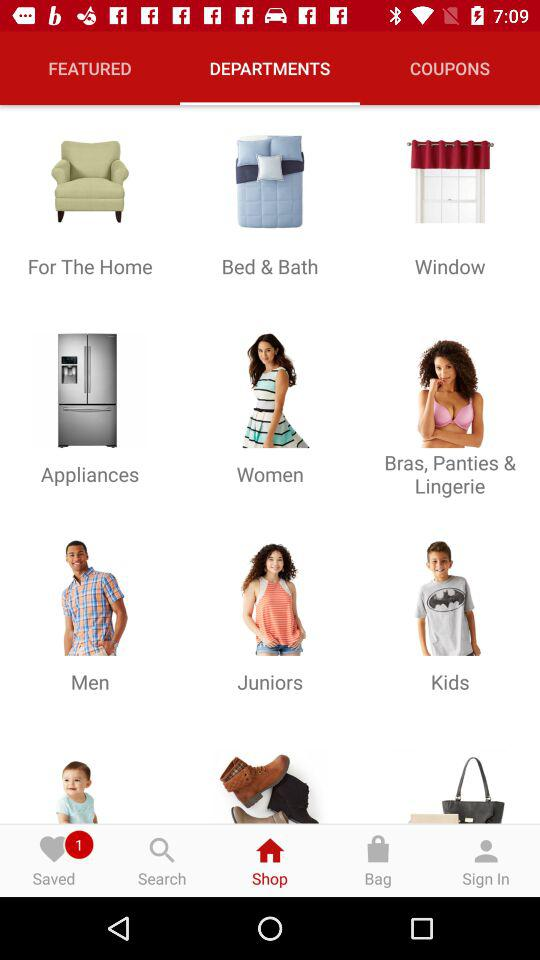Which tab is selected? The selected tabs are "Shop" and "DEPARTMENTS". 